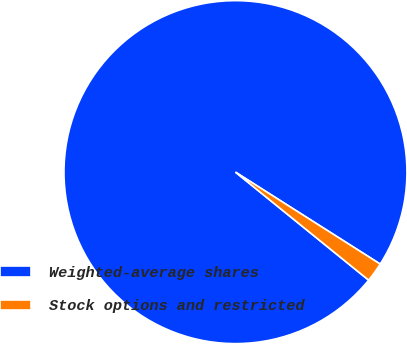Convert chart. <chart><loc_0><loc_0><loc_500><loc_500><pie_chart><fcel>Weighted-average shares<fcel>Stock options and restricted<nl><fcel>98.16%<fcel>1.84%<nl></chart> 